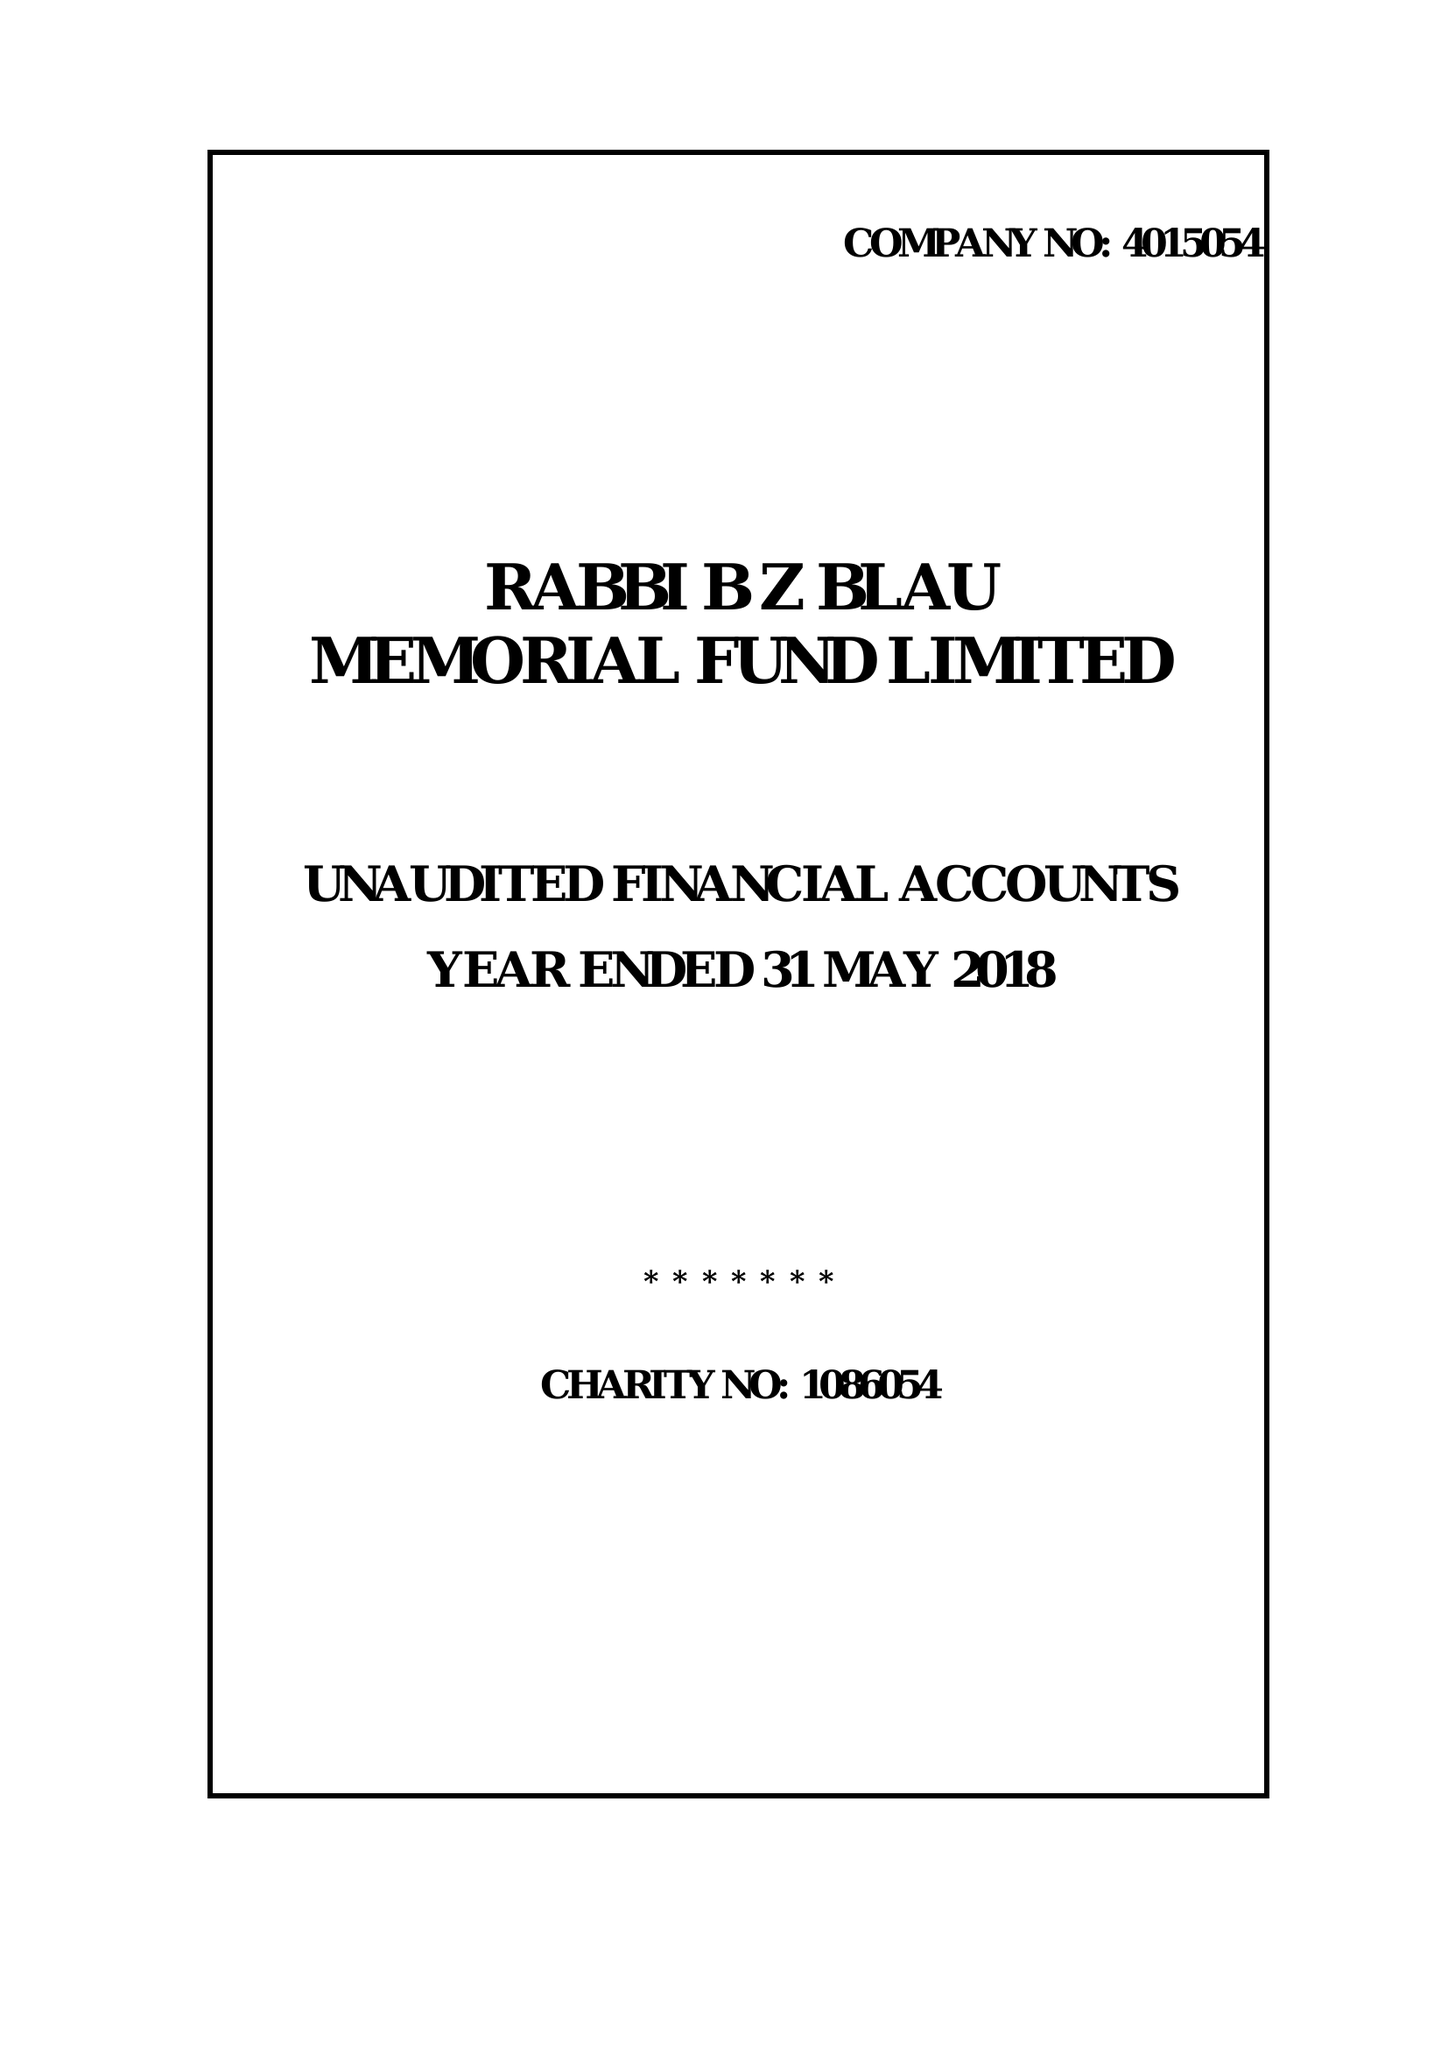What is the value for the spending_annually_in_british_pounds?
Answer the question using a single word or phrase. 33406.00 